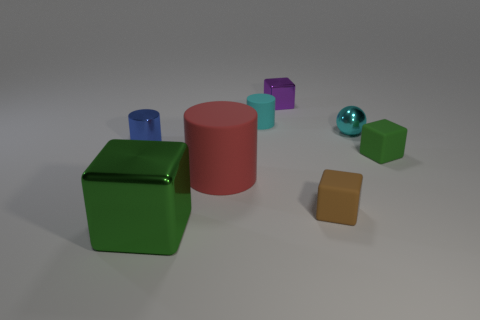Add 2 tiny red spheres. How many objects exist? 10 Subtract all rubber cylinders. How many cylinders are left? 1 Subtract all balls. How many objects are left? 7 Add 8 cyan spheres. How many cyan spheres are left? 9 Add 8 brown matte objects. How many brown matte objects exist? 9 Subtract all cyan cylinders. How many cylinders are left? 2 Subtract 1 cyan spheres. How many objects are left? 7 Subtract 1 cylinders. How many cylinders are left? 2 Subtract all blue balls. Subtract all blue cylinders. How many balls are left? 1 Subtract all brown spheres. How many brown blocks are left? 1 